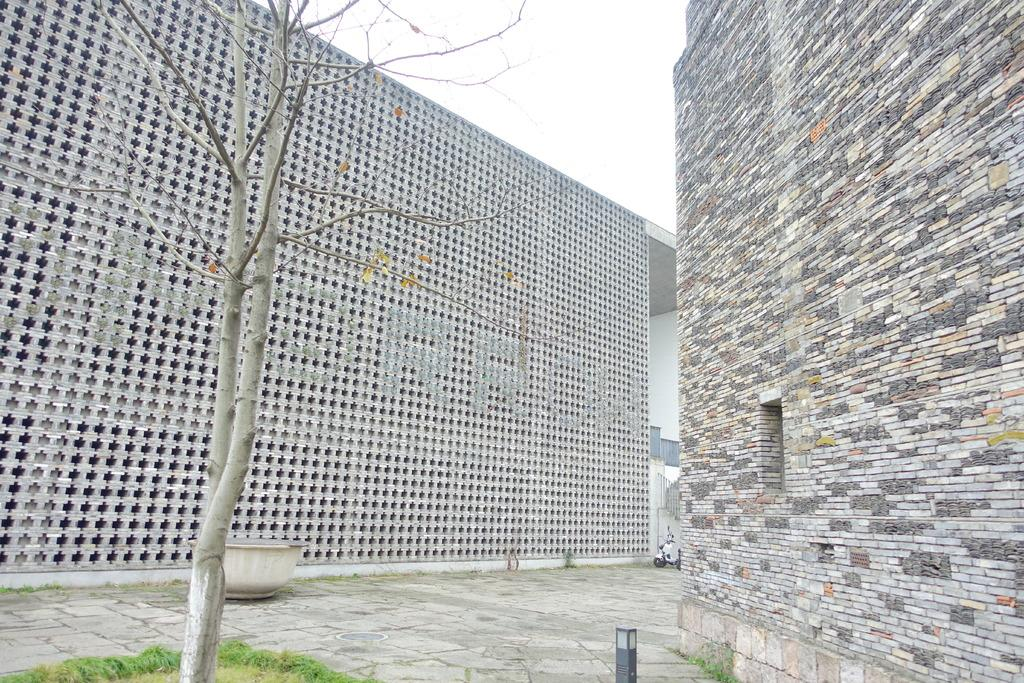What type of structures can be seen in the image? There are buildings in the image. What type of vegetation is present on the ground in the image? There is a tree and grass on the ground in the image. What type of vehicle is parked on the ground in the image? There is a bike parked on the ground in the image. What is the condition of the sky in the image? The sky is clear in the image. What type of stone is used to build the buildings in the image? There is no information about the type of stone used to build the buildings in the image. Can you hear the zipper of the bike in the image? There is no sound or audio information in the image, so it is not possible to hear the zipper of the bike. 